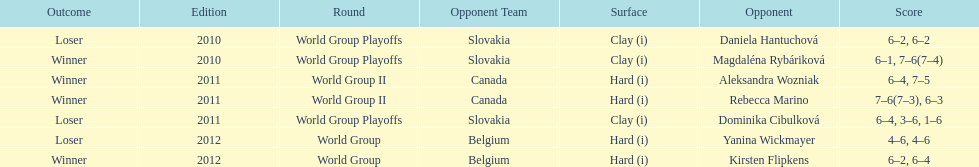Was the contest versus canada subsequent to the contest versus belgium? No. 